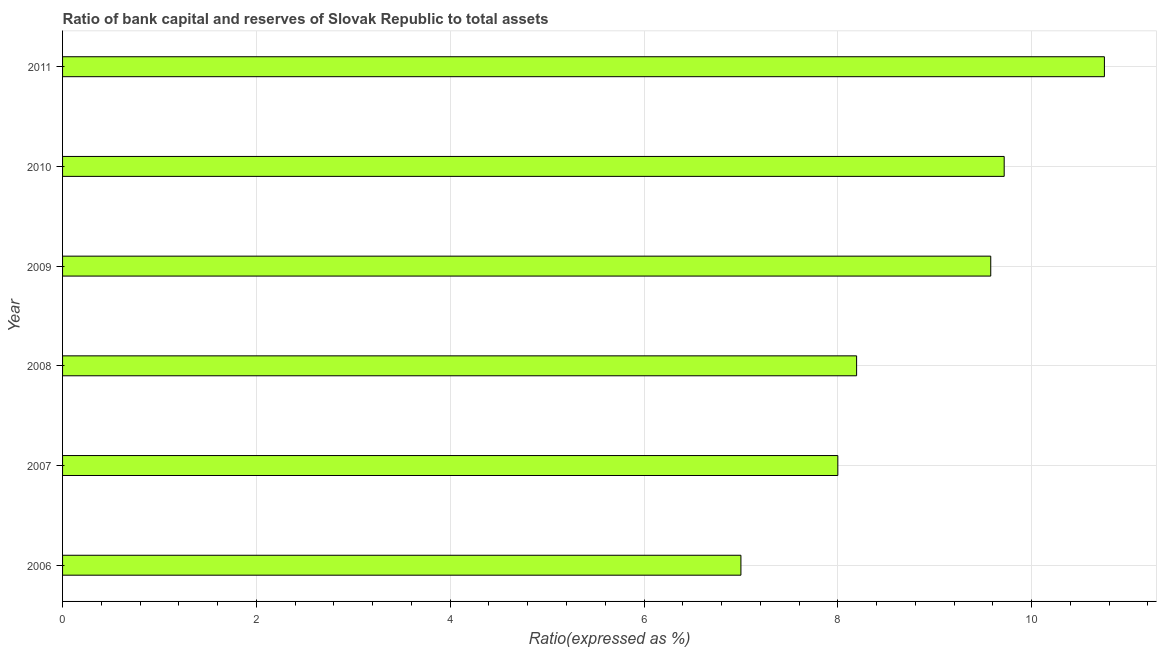Does the graph contain any zero values?
Offer a terse response. No. Does the graph contain grids?
Offer a very short reply. Yes. What is the title of the graph?
Your answer should be compact. Ratio of bank capital and reserves of Slovak Republic to total assets. What is the label or title of the X-axis?
Your answer should be compact. Ratio(expressed as %). Across all years, what is the maximum bank capital to assets ratio?
Make the answer very short. 10.75. Across all years, what is the minimum bank capital to assets ratio?
Keep it short and to the point. 7. In which year was the bank capital to assets ratio minimum?
Give a very brief answer. 2006. What is the sum of the bank capital to assets ratio?
Provide a short and direct response. 53.24. What is the difference between the bank capital to assets ratio in 2008 and 2010?
Your answer should be very brief. -1.52. What is the average bank capital to assets ratio per year?
Your answer should be very brief. 8.87. What is the median bank capital to assets ratio?
Offer a terse response. 8.89. What is the ratio of the bank capital to assets ratio in 2006 to that in 2009?
Keep it short and to the point. 0.73. Is the bank capital to assets ratio in 2006 less than that in 2008?
Your response must be concise. Yes. What is the difference between the highest and the second highest bank capital to assets ratio?
Keep it short and to the point. 1.03. What is the difference between the highest and the lowest bank capital to assets ratio?
Make the answer very short. 3.75. In how many years, is the bank capital to assets ratio greater than the average bank capital to assets ratio taken over all years?
Make the answer very short. 3. Are all the bars in the graph horizontal?
Offer a very short reply. Yes. How many years are there in the graph?
Offer a very short reply. 6. What is the difference between two consecutive major ticks on the X-axis?
Ensure brevity in your answer.  2. What is the Ratio(expressed as %) of 2007?
Your answer should be compact. 8. What is the Ratio(expressed as %) in 2008?
Your answer should be compact. 8.19. What is the Ratio(expressed as %) of 2009?
Your answer should be very brief. 9.58. What is the Ratio(expressed as %) of 2010?
Give a very brief answer. 9.72. What is the Ratio(expressed as %) in 2011?
Offer a terse response. 10.75. What is the difference between the Ratio(expressed as %) in 2006 and 2007?
Offer a terse response. -1. What is the difference between the Ratio(expressed as %) in 2006 and 2008?
Your response must be concise. -1.19. What is the difference between the Ratio(expressed as %) in 2006 and 2009?
Keep it short and to the point. -2.58. What is the difference between the Ratio(expressed as %) in 2006 and 2010?
Keep it short and to the point. -2.72. What is the difference between the Ratio(expressed as %) in 2006 and 2011?
Offer a terse response. -3.75. What is the difference between the Ratio(expressed as %) in 2007 and 2008?
Keep it short and to the point. -0.19. What is the difference between the Ratio(expressed as %) in 2007 and 2009?
Make the answer very short. -1.58. What is the difference between the Ratio(expressed as %) in 2007 and 2010?
Make the answer very short. -1.72. What is the difference between the Ratio(expressed as %) in 2007 and 2011?
Your answer should be compact. -2.75. What is the difference between the Ratio(expressed as %) in 2008 and 2009?
Make the answer very short. -1.38. What is the difference between the Ratio(expressed as %) in 2008 and 2010?
Give a very brief answer. -1.52. What is the difference between the Ratio(expressed as %) in 2008 and 2011?
Make the answer very short. -2.56. What is the difference between the Ratio(expressed as %) in 2009 and 2010?
Ensure brevity in your answer.  -0.14. What is the difference between the Ratio(expressed as %) in 2009 and 2011?
Your answer should be very brief. -1.17. What is the difference between the Ratio(expressed as %) in 2010 and 2011?
Your answer should be compact. -1.03. What is the ratio of the Ratio(expressed as %) in 2006 to that in 2007?
Make the answer very short. 0.88. What is the ratio of the Ratio(expressed as %) in 2006 to that in 2008?
Offer a terse response. 0.85. What is the ratio of the Ratio(expressed as %) in 2006 to that in 2009?
Ensure brevity in your answer.  0.73. What is the ratio of the Ratio(expressed as %) in 2006 to that in 2010?
Ensure brevity in your answer.  0.72. What is the ratio of the Ratio(expressed as %) in 2006 to that in 2011?
Your response must be concise. 0.65. What is the ratio of the Ratio(expressed as %) in 2007 to that in 2008?
Provide a succinct answer. 0.98. What is the ratio of the Ratio(expressed as %) in 2007 to that in 2009?
Offer a terse response. 0.83. What is the ratio of the Ratio(expressed as %) in 2007 to that in 2010?
Ensure brevity in your answer.  0.82. What is the ratio of the Ratio(expressed as %) in 2007 to that in 2011?
Your answer should be compact. 0.74. What is the ratio of the Ratio(expressed as %) in 2008 to that in 2009?
Make the answer very short. 0.85. What is the ratio of the Ratio(expressed as %) in 2008 to that in 2010?
Ensure brevity in your answer.  0.84. What is the ratio of the Ratio(expressed as %) in 2008 to that in 2011?
Keep it short and to the point. 0.76. What is the ratio of the Ratio(expressed as %) in 2009 to that in 2010?
Keep it short and to the point. 0.99. What is the ratio of the Ratio(expressed as %) in 2009 to that in 2011?
Your response must be concise. 0.89. What is the ratio of the Ratio(expressed as %) in 2010 to that in 2011?
Keep it short and to the point. 0.9. 